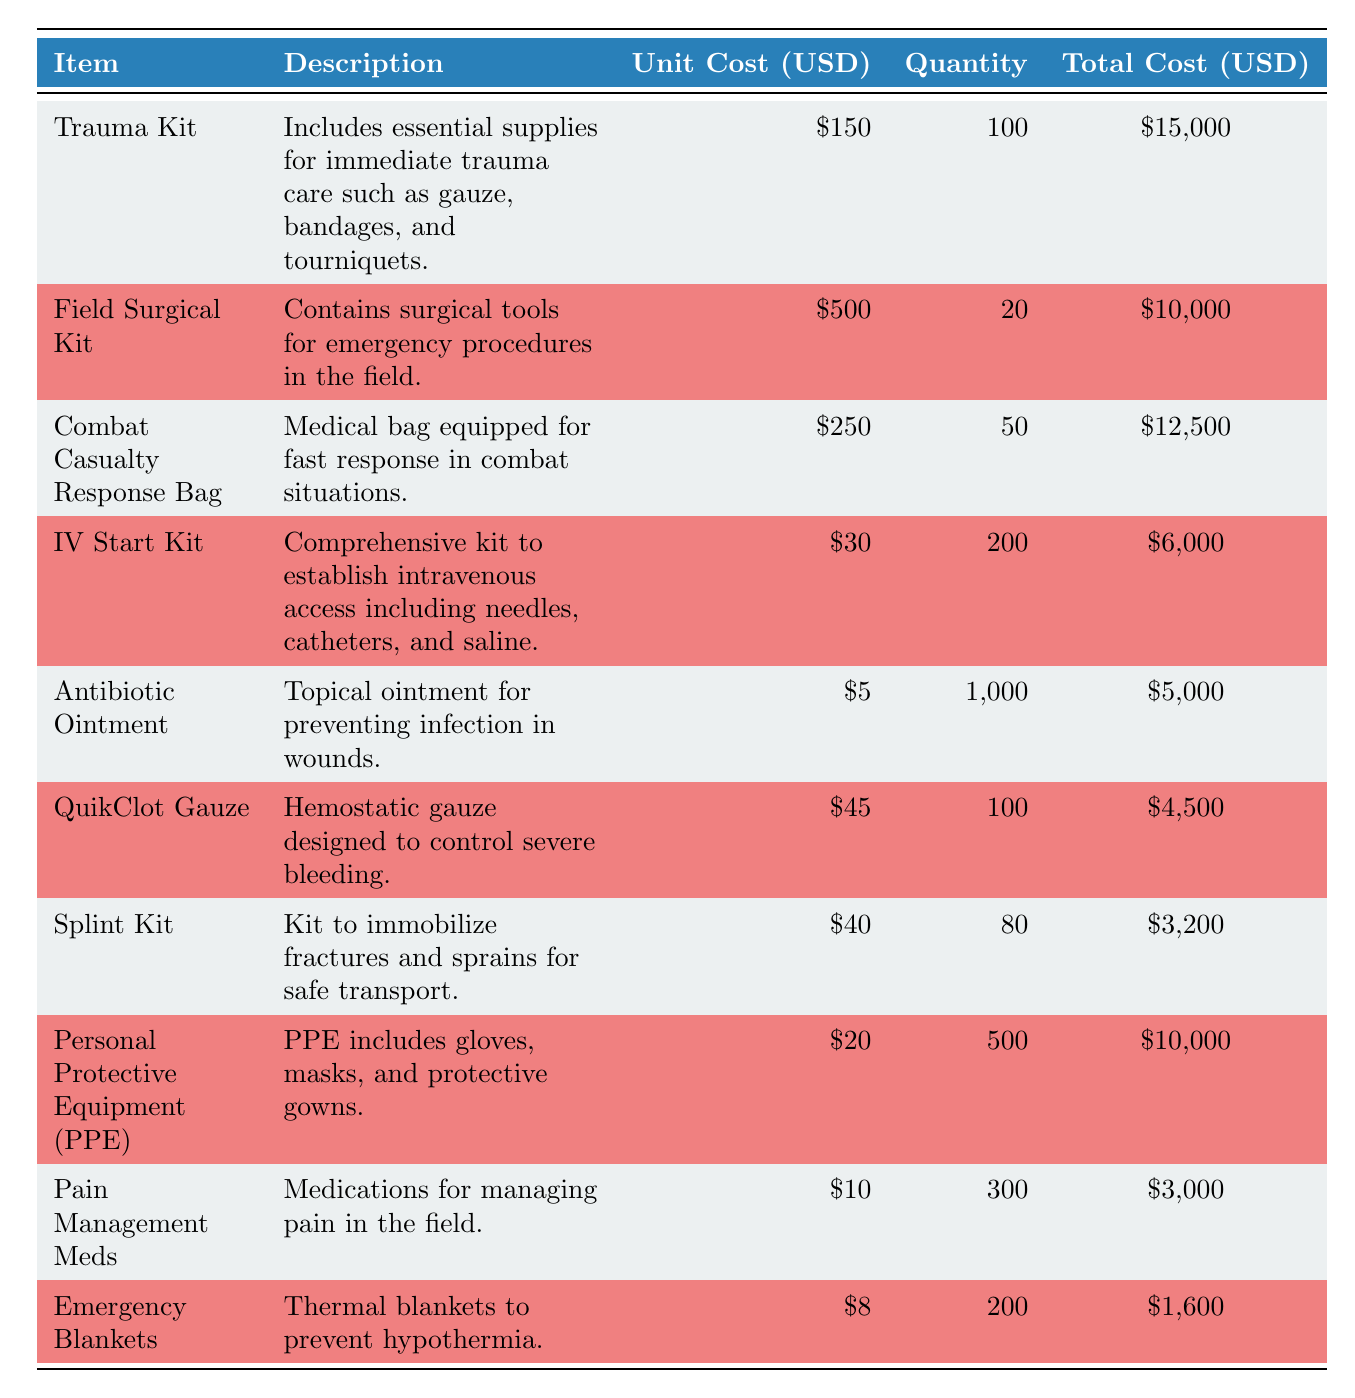What is the total cost of the Trauma Kit? The total cost of the Trauma Kit can be found directly in the table under the "Total Cost (USD)" column. It shows that for 100 units at a unit cost of 150 USD, the total cost is 15,000 USD.
Answer: 15,000 USD How many Emergency Blankets were purchased? The number of Emergency Blankets purchased is listed in the "Quantity Purchased" column. According to the table, 200 units were purchased.
Answer: 200 What is the total cost of all purchased items? To find the total cost of all purchased items, we can sum the "Total Cost (USD)" column. Adding the values: 15,000 + 10,000 + 12,500 + 6,000 + 5,000 + 4,500 + 3,200 + 10,000 + 3,000 + 1,600 equals 70,800 USD.
Answer: 70,800 USD Is the unit cost of the Field Surgical Kit greater than the sum of the unit costs of the Antibiotic Ointment and QuikClot Gauze? The unit cost of the Field Surgical Kit is 500 USD. The sum of the unit costs of the Antibiotic Ointment (5 USD) and QuikClot Gauze (45 USD) is 50 USD. Since 500 is greater than 50, the statement is true.
Answer: Yes What is the average unit cost of the medical supplies listed? To find the average unit cost, we take the total of all unit costs (150 + 500 + 250 + 30 + 5 + 45 + 40 + 20 + 10 + 8 = 1,058) and divide by the number of items (10). So, the average is 1,058 ÷ 10 = 105.8 USD.
Answer: 105.8 USD What percentage of the total cost is attributed to the Personal Protective Equipment (PPE)? The total cost of PPE is 10,000 USD. To find what percentage this is of the total cost (70,800 USD), we calculate (10,000 / 70,800) * 100, which gives approximately 14.1%.
Answer: 14.1% How much more expensive is the Field Surgical Kit compared to the average unit cost of the other kits? The Field Surgical Kit costs 500 USD. Excluding it for the average cost calculation of the other kits: (150 + 30 + 250 + 45 + 40 + 20 + 10 + 8 = 553) over 8 kits gives an average of 69.125 USD. Thus, the difference is 500 - 69.125 = 430.875 USD.
Answer: 430.875 USD Is it true that more Pain Management Meds were purchased than QuikClot Gauze? From the table, 300 units of Pain Management Meds were purchased, while only 100 units of QuikClot Gauze were purchased. Therefore, it is true that more Pain Management Meds were purchased.
Answer: Yes 